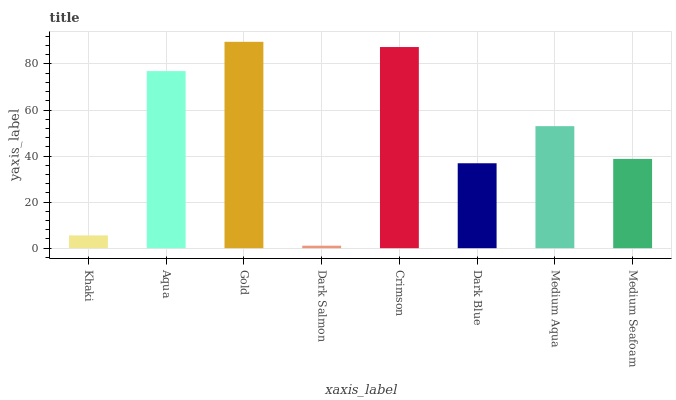Is Aqua the minimum?
Answer yes or no. No. Is Aqua the maximum?
Answer yes or no. No. Is Aqua greater than Khaki?
Answer yes or no. Yes. Is Khaki less than Aqua?
Answer yes or no. Yes. Is Khaki greater than Aqua?
Answer yes or no. No. Is Aqua less than Khaki?
Answer yes or no. No. Is Medium Aqua the high median?
Answer yes or no. Yes. Is Medium Seafoam the low median?
Answer yes or no. Yes. Is Dark Blue the high median?
Answer yes or no. No. Is Dark Salmon the low median?
Answer yes or no. No. 